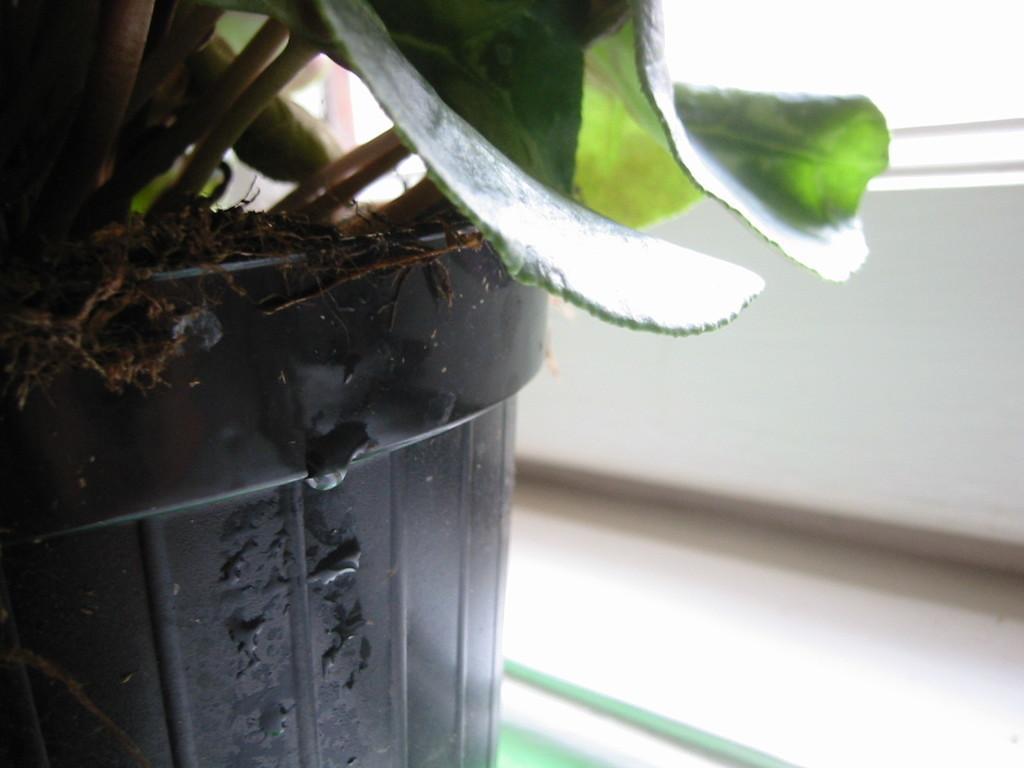Can you describe this image briefly? In this image we can see a plant with leaves is placed in a pot kept on the surface. 